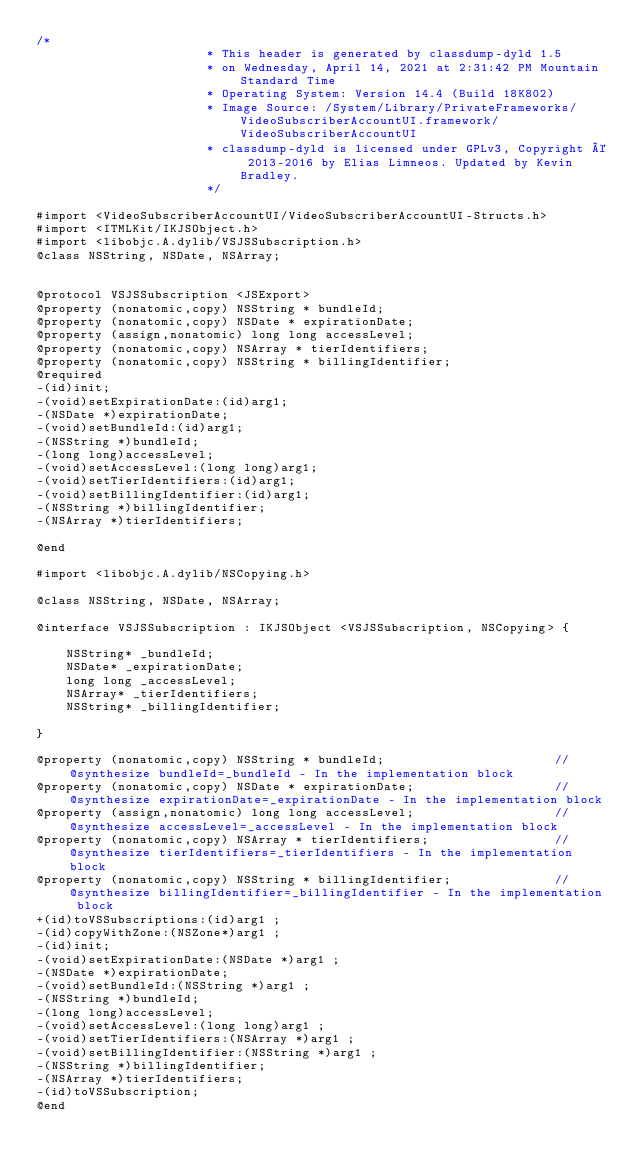Convert code to text. <code><loc_0><loc_0><loc_500><loc_500><_C_>/*
                       * This header is generated by classdump-dyld 1.5
                       * on Wednesday, April 14, 2021 at 2:31:42 PM Mountain Standard Time
                       * Operating System: Version 14.4 (Build 18K802)
                       * Image Source: /System/Library/PrivateFrameworks/VideoSubscriberAccountUI.framework/VideoSubscriberAccountUI
                       * classdump-dyld is licensed under GPLv3, Copyright © 2013-2016 by Elias Limneos. Updated by Kevin Bradley.
                       */

#import <VideoSubscriberAccountUI/VideoSubscriberAccountUI-Structs.h>
#import <ITMLKit/IKJSObject.h>
#import <libobjc.A.dylib/VSJSSubscription.h>
@class NSString, NSDate, NSArray;


@protocol VSJSSubscription <JSExport>
@property (nonatomic,copy) NSString * bundleId; 
@property (nonatomic,copy) NSDate * expirationDate; 
@property (assign,nonatomic) long long accessLevel; 
@property (nonatomic,copy) NSArray * tierIdentifiers; 
@property (nonatomic,copy) NSString * billingIdentifier; 
@required
-(id)init;
-(void)setExpirationDate:(id)arg1;
-(NSDate *)expirationDate;
-(void)setBundleId:(id)arg1;
-(NSString *)bundleId;
-(long long)accessLevel;
-(void)setAccessLevel:(long long)arg1;
-(void)setTierIdentifiers:(id)arg1;
-(void)setBillingIdentifier:(id)arg1;
-(NSString *)billingIdentifier;
-(NSArray *)tierIdentifiers;

@end

#import <libobjc.A.dylib/NSCopying.h>

@class NSString, NSDate, NSArray;

@interface VSJSSubscription : IKJSObject <VSJSSubscription, NSCopying> {

	NSString* _bundleId;
	NSDate* _expirationDate;
	long long _accessLevel;
	NSArray* _tierIdentifiers;
	NSString* _billingIdentifier;

}

@property (nonatomic,copy) NSString * bundleId;                       //@synthesize bundleId=_bundleId - In the implementation block
@property (nonatomic,copy) NSDate * expirationDate;                   //@synthesize expirationDate=_expirationDate - In the implementation block
@property (assign,nonatomic) long long accessLevel;                   //@synthesize accessLevel=_accessLevel - In the implementation block
@property (nonatomic,copy) NSArray * tierIdentifiers;                 //@synthesize tierIdentifiers=_tierIdentifiers - In the implementation block
@property (nonatomic,copy) NSString * billingIdentifier;              //@synthesize billingIdentifier=_billingIdentifier - In the implementation block
+(id)toVSSubscriptions:(id)arg1 ;
-(id)copyWithZone:(NSZone*)arg1 ;
-(id)init;
-(void)setExpirationDate:(NSDate *)arg1 ;
-(NSDate *)expirationDate;
-(void)setBundleId:(NSString *)arg1 ;
-(NSString *)bundleId;
-(long long)accessLevel;
-(void)setAccessLevel:(long long)arg1 ;
-(void)setTierIdentifiers:(NSArray *)arg1 ;
-(void)setBillingIdentifier:(NSString *)arg1 ;
-(NSString *)billingIdentifier;
-(NSArray *)tierIdentifiers;
-(id)toVSSubscription;
@end

</code> 